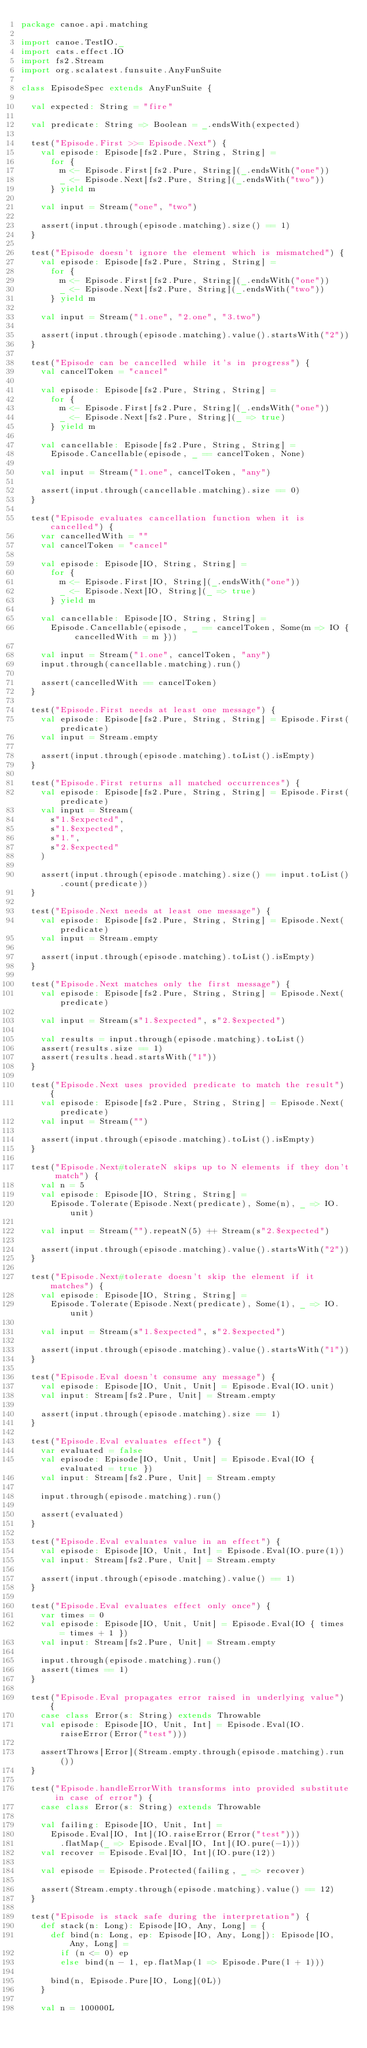<code> <loc_0><loc_0><loc_500><loc_500><_Scala_>package canoe.api.matching

import canoe.TestIO._
import cats.effect.IO
import fs2.Stream
import org.scalatest.funsuite.AnyFunSuite

class EpisodeSpec extends AnyFunSuite {

  val expected: String = "fire"

  val predicate: String => Boolean = _.endsWith(expected)

  test("Episode.First >>= Episode.Next") {
    val episode: Episode[fs2.Pure, String, String] =
      for {
        m <- Episode.First[fs2.Pure, String](_.endsWith("one"))
        _ <- Episode.Next[fs2.Pure, String](_.endsWith("two"))
      } yield m

    val input = Stream("one", "two")

    assert(input.through(episode.matching).size() == 1)
  }

  test("Episode doesn't ignore the element which is mismatched") {
    val episode: Episode[fs2.Pure, String, String] =
      for {
        m <- Episode.First[fs2.Pure, String](_.endsWith("one"))
        _ <- Episode.Next[fs2.Pure, String](_.endsWith("two"))
      } yield m

    val input = Stream("1.one", "2.one", "3.two")

    assert(input.through(episode.matching).value().startsWith("2"))
  }

  test("Episode can be cancelled while it's in progress") {
    val cancelToken = "cancel"

    val episode: Episode[fs2.Pure, String, String] =
      for {
        m <- Episode.First[fs2.Pure, String](_.endsWith("one"))
        _ <- Episode.Next[fs2.Pure, String](_ => true)
      } yield m

    val cancellable: Episode[fs2.Pure, String, String] =
      Episode.Cancellable(episode, _ == cancelToken, None)

    val input = Stream("1.one", cancelToken, "any")

    assert(input.through(cancellable.matching).size == 0)
  }

  test("Episode evaluates cancellation function when it is cancelled") {
    var cancelledWith = ""
    val cancelToken = "cancel"

    val episode: Episode[IO, String, String] =
      for {
        m <- Episode.First[IO, String](_.endsWith("one"))
        _ <- Episode.Next[IO, String](_ => true)
      } yield m

    val cancellable: Episode[IO, String, String] =
      Episode.Cancellable(episode, _ == cancelToken, Some(m => IO { cancelledWith = m }))

    val input = Stream("1.one", cancelToken, "any")
    input.through(cancellable.matching).run()

    assert(cancelledWith == cancelToken)
  }

  test("Episode.First needs at least one message") {
    val episode: Episode[fs2.Pure, String, String] = Episode.First(predicate)
    val input = Stream.empty

    assert(input.through(episode.matching).toList().isEmpty)
  }

  test("Episode.First returns all matched occurrences") {
    val episode: Episode[fs2.Pure, String, String] = Episode.First(predicate)
    val input = Stream(
      s"1.$expected",
      s"1.$expected",
      s"1.",
      s"2.$expected"
    )

    assert(input.through(episode.matching).size() == input.toList().count(predicate))
  }

  test("Episode.Next needs at least one message") {
    val episode: Episode[fs2.Pure, String, String] = Episode.Next(predicate)
    val input = Stream.empty

    assert(input.through(episode.matching).toList().isEmpty)
  }

  test("Episode.Next matches only the first message") {
    val episode: Episode[fs2.Pure, String, String] = Episode.Next(predicate)

    val input = Stream(s"1.$expected", s"2.$expected")

    val results = input.through(episode.matching).toList()
    assert(results.size == 1)
    assert(results.head.startsWith("1"))
  }

  test("Episode.Next uses provided predicate to match the result") {
    val episode: Episode[fs2.Pure, String, String] = Episode.Next(predicate)
    val input = Stream("")

    assert(input.through(episode.matching).toList().isEmpty)
  }

  test("Episode.Next#tolerateN skips up to N elements if they don't match") {
    val n = 5
    val episode: Episode[IO, String, String] =
      Episode.Tolerate(Episode.Next(predicate), Some(n), _ => IO.unit)

    val input = Stream("").repeatN(5) ++ Stream(s"2.$expected")

    assert(input.through(episode.matching).value().startsWith("2"))
  }

  test("Episode.Next#tolerate doesn't skip the element if it matches") {
    val episode: Episode[IO, String, String] =
      Episode.Tolerate(Episode.Next(predicate), Some(1), _ => IO.unit)

    val input = Stream(s"1.$expected", s"2.$expected")

    assert(input.through(episode.matching).value().startsWith("1"))
  }

  test("Episode.Eval doesn't consume any message") {
    val episode: Episode[IO, Unit, Unit] = Episode.Eval(IO.unit)
    val input: Stream[fs2.Pure, Unit] = Stream.empty

    assert(input.through(episode.matching).size == 1)
  }

  test("Episode.Eval evaluates effect") {
    var evaluated = false
    val episode: Episode[IO, Unit, Unit] = Episode.Eval(IO { evaluated = true })
    val input: Stream[fs2.Pure, Unit] = Stream.empty

    input.through(episode.matching).run()

    assert(evaluated)
  }

  test("Episode.Eval evaluates value in an effect") {
    val episode: Episode[IO, Unit, Int] = Episode.Eval(IO.pure(1))
    val input: Stream[fs2.Pure, Unit] = Stream.empty

    assert(input.through(episode.matching).value() == 1)
  }

  test("Episode.Eval evaluates effect only once") {
    var times = 0
    val episode: Episode[IO, Unit, Unit] = Episode.Eval(IO { times = times + 1 })
    val input: Stream[fs2.Pure, Unit] = Stream.empty

    input.through(episode.matching).run()
    assert(times == 1)
  }

  test("Episode.Eval propagates error raised in underlying value") {
    case class Error(s: String) extends Throwable
    val episode: Episode[IO, Unit, Int] = Episode.Eval(IO.raiseError(Error("test")))

    assertThrows[Error](Stream.empty.through(episode.matching).run())
  }

  test("Episode.handleErrorWith transforms into provided substitute in case of error") {
    case class Error(s: String) extends Throwable

    val failing: Episode[IO, Unit, Int] =
      Episode.Eval[IO, Int](IO.raiseError(Error("test")))
        .flatMap(_ => Episode.Eval[IO, Int](IO.pure(-1)))
    val recover = Episode.Eval[IO, Int](IO.pure(12))

    val episode = Episode.Protected(failing, _ => recover)

    assert(Stream.empty.through(episode.matching).value() == 12)
  }

  test("Episode is stack safe during the interpretation") {
    def stack(n: Long): Episode[IO, Any, Long] = {
      def bind(n: Long, ep: Episode[IO, Any, Long]): Episode[IO, Any, Long] =
        if (n <= 0) ep
        else bind(n - 1, ep.flatMap(l => Episode.Pure(l + 1)))

      bind(n, Episode.Pure[IO, Long](0L))
    }

    val n = 100000L</code> 